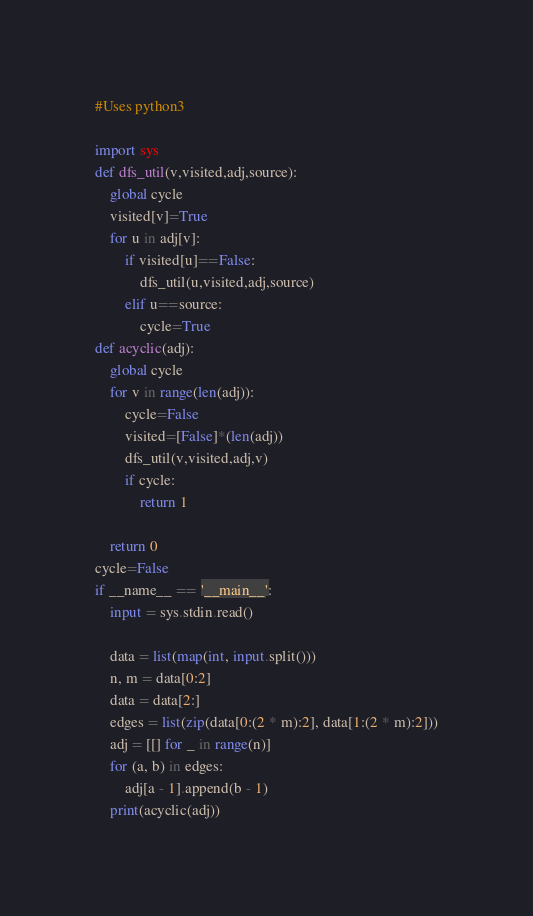<code> <loc_0><loc_0><loc_500><loc_500><_Python_>#Uses python3

import sys
def dfs_util(v,visited,adj,source):
    global cycle
    visited[v]=True
    for u in adj[v]:
        if visited[u]==False:
            dfs_util(u,visited,adj,source)
        elif u==source:
            cycle=True
def acyclic(adj):
    global cycle
    for v in range(len(adj)):
        cycle=False
        visited=[False]*(len(adj))
        dfs_util(v,visited,adj,v)
        if cycle:
            return 1

    return 0
cycle=False
if __name__ == '__main__':
    input = sys.stdin.read()

    data = list(map(int, input.split()))
    n, m = data[0:2]
    data = data[2:]
    edges = list(zip(data[0:(2 * m):2], data[1:(2 * m):2]))
    adj = [[] for _ in range(n)]
    for (a, b) in edges:
        adj[a - 1].append(b - 1)
    print(acyclic(adj))
</code> 